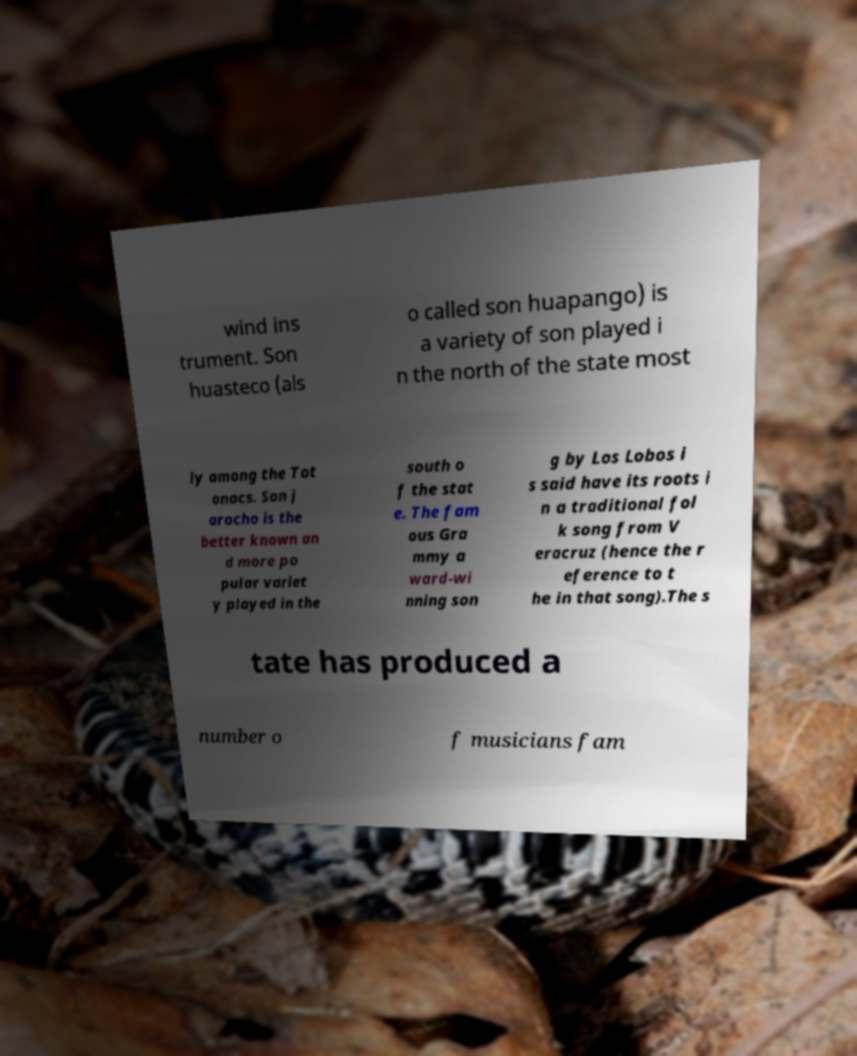Please read and relay the text visible in this image. What does it say? wind ins trument. Son huasteco (als o called son huapango) is a variety of son played i n the north of the state most ly among the Tot onacs. Son j arocho is the better known an d more po pular variet y played in the south o f the stat e. The fam ous Gra mmy a ward-wi nning son g by Los Lobos i s said have its roots i n a traditional fol k song from V eracruz (hence the r eference to t he in that song).The s tate has produced a number o f musicians fam 